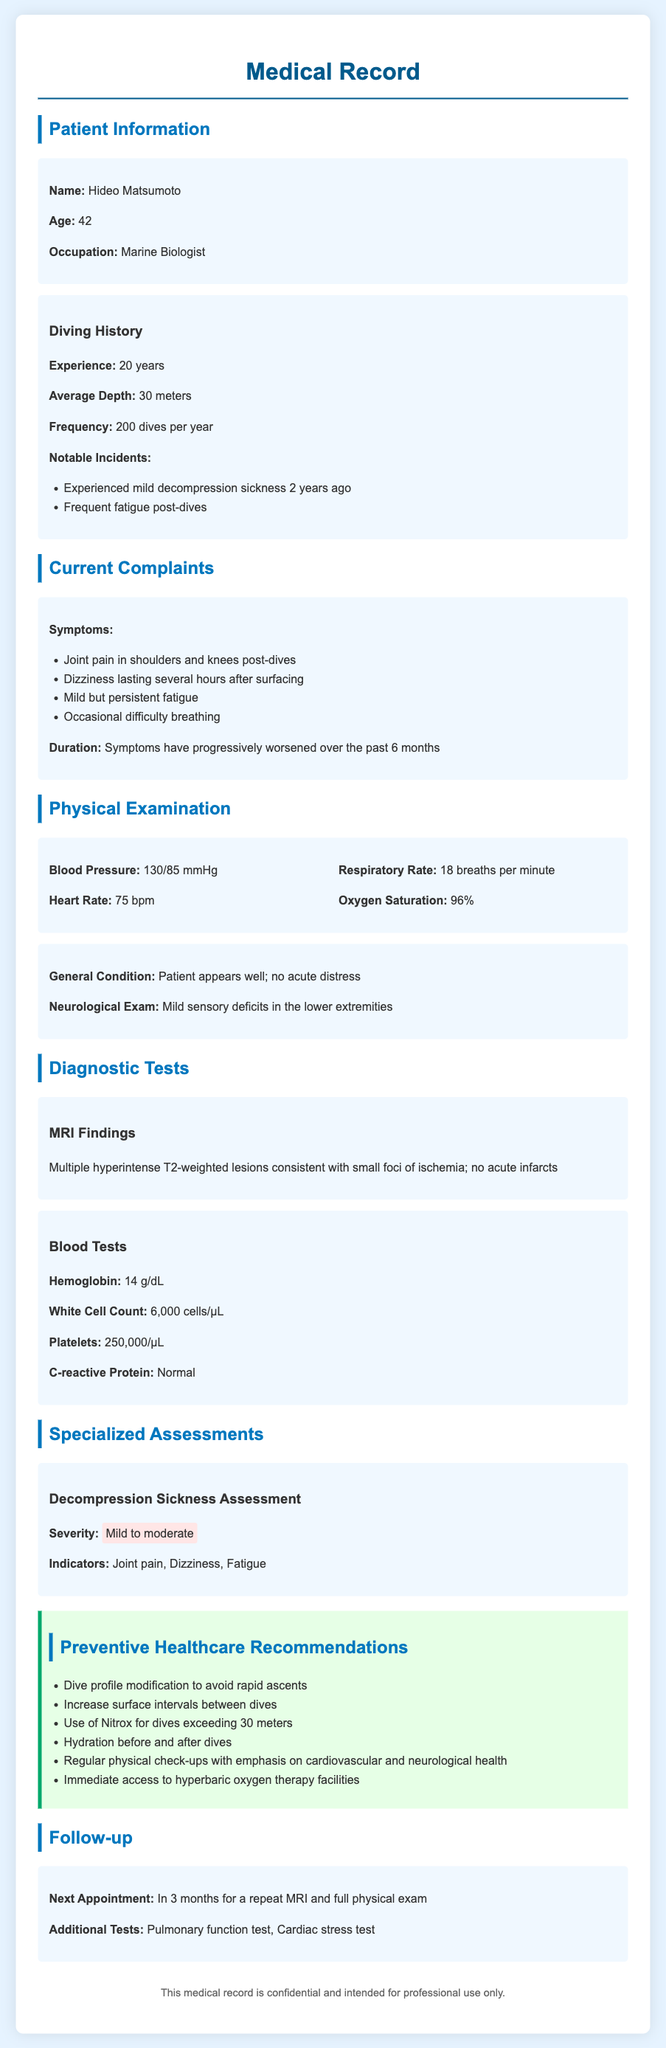What is the patient's name? The patient's name is listed at the beginning of the document under Patient Information.
Answer: Hideo Matsumoto How many years of diving experience does the patient have? The diving history section specifies the patient's experience in years.
Answer: 20 years What symptoms are reported by the patient? The current complaints section includes a list of symptoms experienced by the patient.
Answer: Joint pain, dizziness, fatigue, difficulty breathing What is the patient's blood pressure reading? The physical examination section provides the patient's blood pressure measurement.
Answer: 130/85 mmHg What kind of therapy should be accessible immediately as per recommendations? The preventive healthcare recommendations specify a therapy that should be available for the patient.
Answer: Hyperbaric oxygen therapy What does the MRI findings indicate? The diagnostic tests section states the findings of the MRI.
Answer: Small foci of ischemia What is the severity of the decompression sickness assessed? The specialized assessments section provides the severity of the patient's decompression sickness.
Answer: Mild to moderate When is the patient's next appointment scheduled? The follow-up section states when the patient's next appointment will take place.
Answer: In 3 months 